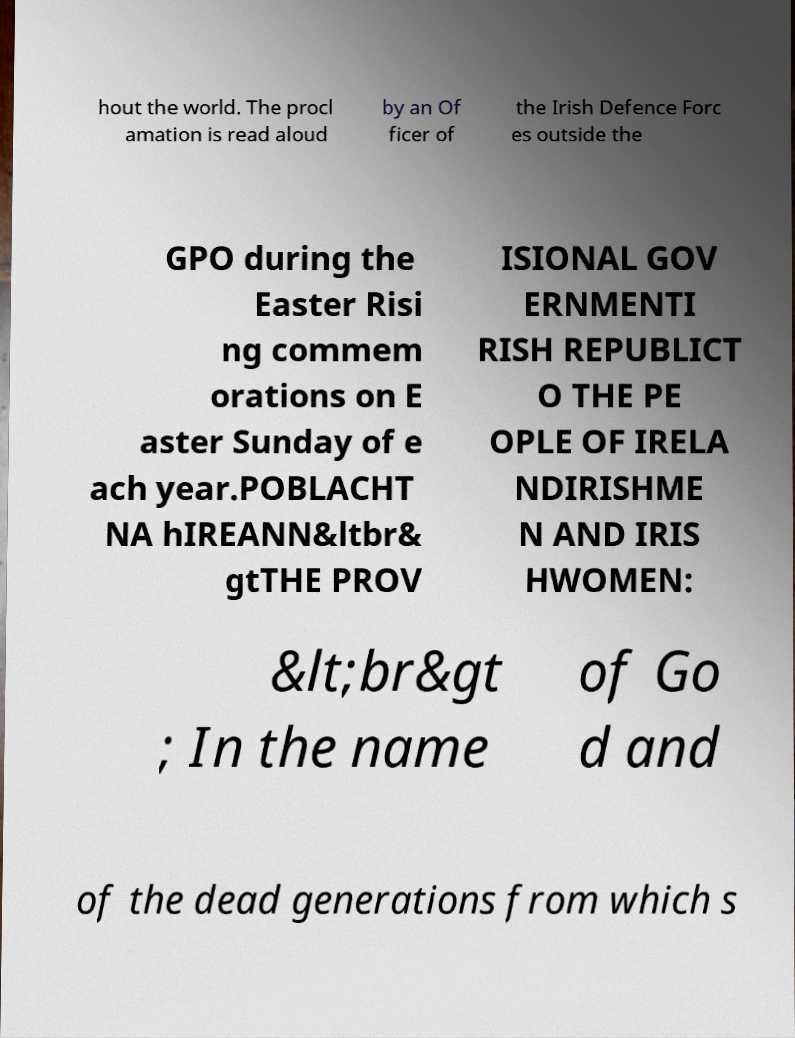Please read and relay the text visible in this image. What does it say? hout the world. The procl amation is read aloud by an Of ficer of the Irish Defence Forc es outside the GPO during the Easter Risi ng commem orations on E aster Sunday of e ach year.POBLACHT NA hIREANN&ltbr& gtTHE PROV ISIONAL GOV ERNMENTI RISH REPUBLICT O THE PE OPLE OF IRELA NDIRISHME N AND IRIS HWOMEN: &lt;br&gt ; In the name of Go d and of the dead generations from which s 